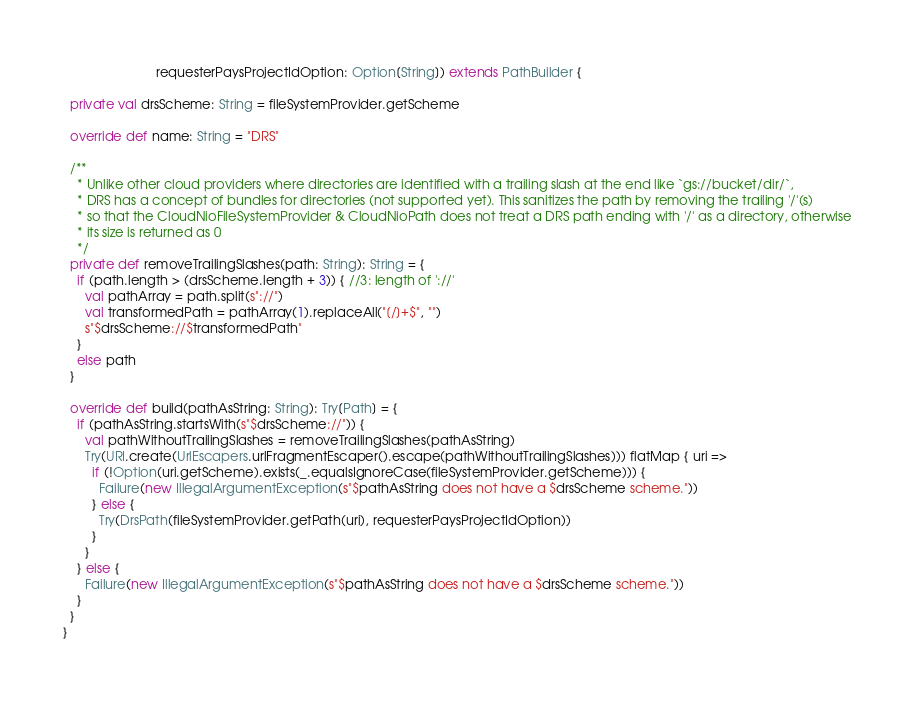Convert code to text. <code><loc_0><loc_0><loc_500><loc_500><_Scala_>                          requesterPaysProjectIdOption: Option[String]) extends PathBuilder {

  private val drsScheme: String = fileSystemProvider.getScheme

  override def name: String = "DRS"

  /**
    * Unlike other cloud providers where directories are identified with a trailing slash at the end like `gs://bucket/dir/`,
    * DRS has a concept of bundles for directories (not supported yet). This sanitizes the path by removing the trailing '/'(s)
    * so that the CloudNioFileSystemProvider & CloudNioPath does not treat a DRS path ending with '/' as a directory, otherwise
    * its size is returned as 0
    */
  private def removeTrailingSlashes(path: String): String = {
    if (path.length > (drsScheme.length + 3)) { //3: length of '://'
      val pathArray = path.split(s"://")
      val transformedPath = pathArray(1).replaceAll("[/]+$", "")
      s"$drsScheme://$transformedPath"
    }
    else path
  }

  override def build(pathAsString: String): Try[Path] = {
    if (pathAsString.startsWith(s"$drsScheme://")) {
      val pathWithoutTrailingSlashes = removeTrailingSlashes(pathAsString)
      Try(URI.create(UrlEscapers.urlFragmentEscaper().escape(pathWithoutTrailingSlashes))) flatMap { uri =>
        if (!Option(uri.getScheme).exists(_.equalsIgnoreCase(fileSystemProvider.getScheme))) {
          Failure(new IllegalArgumentException(s"$pathAsString does not have a $drsScheme scheme."))
        } else {
          Try(DrsPath(fileSystemProvider.getPath(uri), requesterPaysProjectIdOption))
        }
      }
    } else {
      Failure(new IllegalArgumentException(s"$pathAsString does not have a $drsScheme scheme."))
    }
  }
}
</code> 